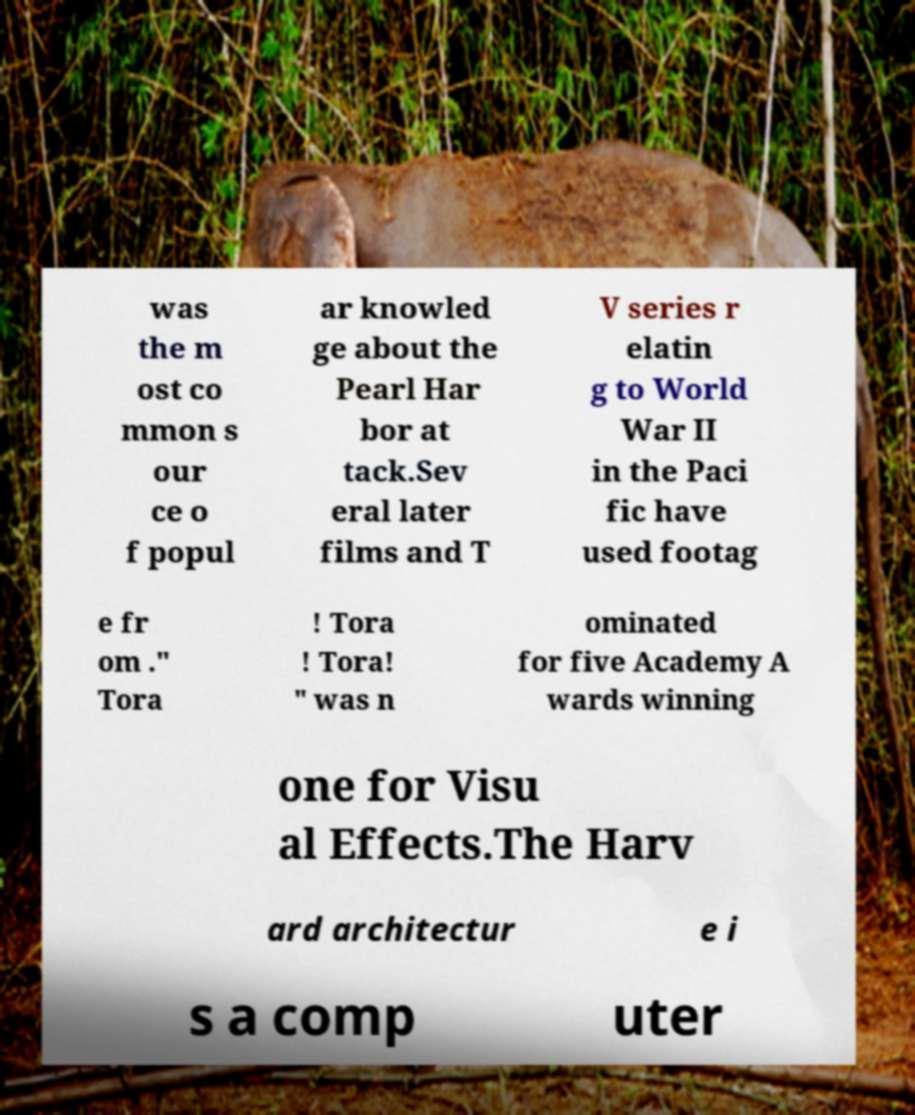Please read and relay the text visible in this image. What does it say? was the m ost co mmon s our ce o f popul ar knowled ge about the Pearl Har bor at tack.Sev eral later films and T V series r elatin g to World War II in the Paci fic have used footag e fr om ." Tora ! Tora ! Tora! " was n ominated for five Academy A wards winning one for Visu al Effects.The Harv ard architectur e i s a comp uter 